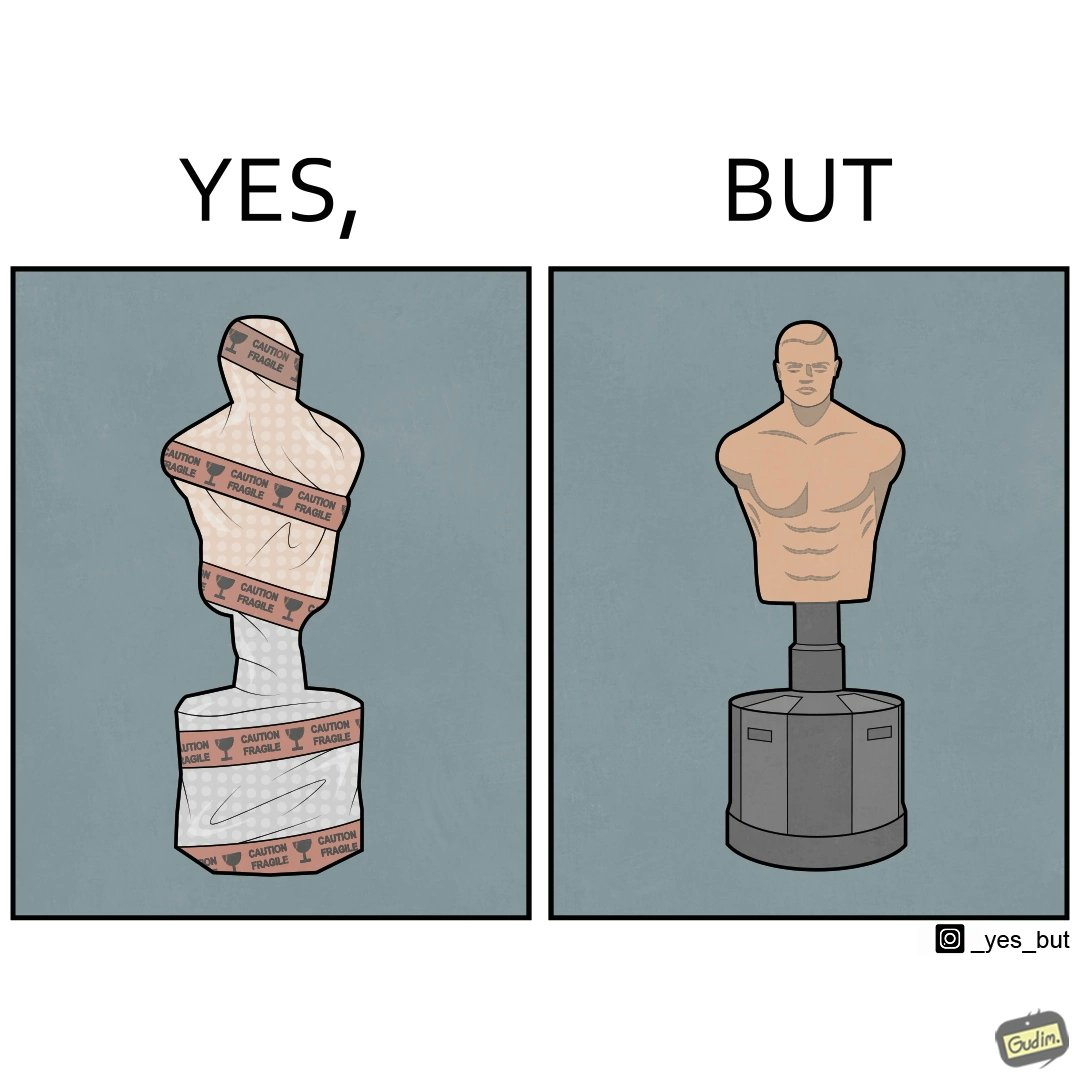Why is this image considered satirical? The image is funny because the object which is said to be fragile by the tape turns out to be an equipment to practice punches and kicks on meaning that it is very tought and sturdy. 